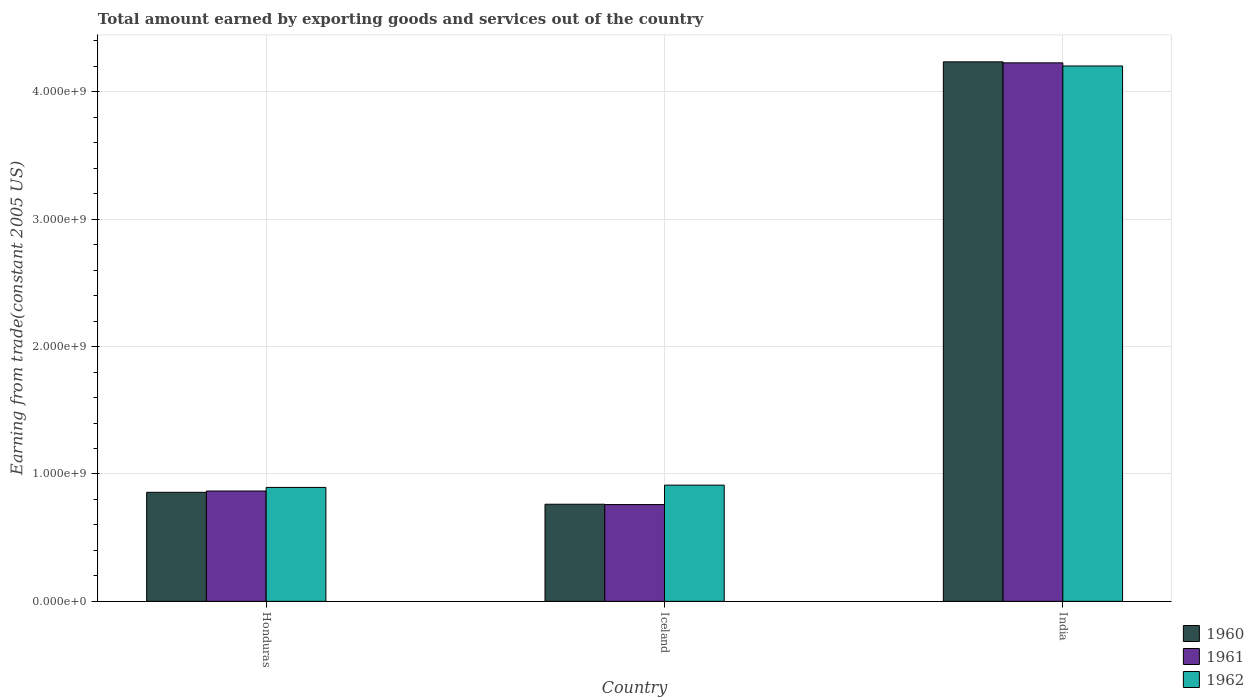How many bars are there on the 2nd tick from the left?
Offer a very short reply. 3. How many bars are there on the 2nd tick from the right?
Your response must be concise. 3. What is the label of the 3rd group of bars from the left?
Your answer should be very brief. India. What is the total amount earned by exporting goods and services in 1961 in India?
Your response must be concise. 4.23e+09. Across all countries, what is the maximum total amount earned by exporting goods and services in 1960?
Ensure brevity in your answer.  4.24e+09. Across all countries, what is the minimum total amount earned by exporting goods and services in 1961?
Make the answer very short. 7.60e+08. In which country was the total amount earned by exporting goods and services in 1962 maximum?
Your response must be concise. India. In which country was the total amount earned by exporting goods and services in 1962 minimum?
Your answer should be very brief. Honduras. What is the total total amount earned by exporting goods and services in 1962 in the graph?
Offer a very short reply. 6.01e+09. What is the difference between the total amount earned by exporting goods and services in 1962 in Honduras and that in India?
Offer a very short reply. -3.31e+09. What is the difference between the total amount earned by exporting goods and services in 1962 in Iceland and the total amount earned by exporting goods and services in 1960 in Honduras?
Offer a very short reply. 5.63e+07. What is the average total amount earned by exporting goods and services in 1960 per country?
Your response must be concise. 1.95e+09. What is the difference between the total amount earned by exporting goods and services of/in 1962 and total amount earned by exporting goods and services of/in 1961 in India?
Keep it short and to the point. -2.45e+07. What is the ratio of the total amount earned by exporting goods and services in 1960 in Honduras to that in Iceland?
Keep it short and to the point. 1.12. What is the difference between the highest and the second highest total amount earned by exporting goods and services in 1960?
Give a very brief answer. -3.38e+09. What is the difference between the highest and the lowest total amount earned by exporting goods and services in 1962?
Offer a terse response. 3.31e+09. Is the sum of the total amount earned by exporting goods and services in 1961 in Iceland and India greater than the maximum total amount earned by exporting goods and services in 1960 across all countries?
Offer a terse response. Yes. Are the values on the major ticks of Y-axis written in scientific E-notation?
Your answer should be very brief. Yes. Does the graph contain any zero values?
Give a very brief answer. No. What is the title of the graph?
Ensure brevity in your answer.  Total amount earned by exporting goods and services out of the country. What is the label or title of the Y-axis?
Provide a short and direct response. Earning from trade(constant 2005 US). What is the Earning from trade(constant 2005 US) in 1960 in Honduras?
Ensure brevity in your answer.  8.56e+08. What is the Earning from trade(constant 2005 US) of 1961 in Honduras?
Keep it short and to the point. 8.66e+08. What is the Earning from trade(constant 2005 US) of 1962 in Honduras?
Offer a very short reply. 8.95e+08. What is the Earning from trade(constant 2005 US) in 1960 in Iceland?
Make the answer very short. 7.62e+08. What is the Earning from trade(constant 2005 US) of 1961 in Iceland?
Your answer should be compact. 7.60e+08. What is the Earning from trade(constant 2005 US) in 1962 in Iceland?
Your answer should be compact. 9.12e+08. What is the Earning from trade(constant 2005 US) of 1960 in India?
Ensure brevity in your answer.  4.24e+09. What is the Earning from trade(constant 2005 US) of 1961 in India?
Your answer should be compact. 4.23e+09. What is the Earning from trade(constant 2005 US) in 1962 in India?
Provide a short and direct response. 4.20e+09. Across all countries, what is the maximum Earning from trade(constant 2005 US) of 1960?
Provide a succinct answer. 4.24e+09. Across all countries, what is the maximum Earning from trade(constant 2005 US) in 1961?
Provide a succinct answer. 4.23e+09. Across all countries, what is the maximum Earning from trade(constant 2005 US) in 1962?
Give a very brief answer. 4.20e+09. Across all countries, what is the minimum Earning from trade(constant 2005 US) of 1960?
Give a very brief answer. 7.62e+08. Across all countries, what is the minimum Earning from trade(constant 2005 US) of 1961?
Your answer should be compact. 7.60e+08. Across all countries, what is the minimum Earning from trade(constant 2005 US) in 1962?
Ensure brevity in your answer.  8.95e+08. What is the total Earning from trade(constant 2005 US) of 1960 in the graph?
Keep it short and to the point. 5.85e+09. What is the total Earning from trade(constant 2005 US) in 1961 in the graph?
Your answer should be compact. 5.85e+09. What is the total Earning from trade(constant 2005 US) in 1962 in the graph?
Your response must be concise. 6.01e+09. What is the difference between the Earning from trade(constant 2005 US) in 1960 in Honduras and that in Iceland?
Your answer should be compact. 9.37e+07. What is the difference between the Earning from trade(constant 2005 US) in 1961 in Honduras and that in Iceland?
Ensure brevity in your answer.  1.06e+08. What is the difference between the Earning from trade(constant 2005 US) in 1962 in Honduras and that in Iceland?
Your answer should be very brief. -1.79e+07. What is the difference between the Earning from trade(constant 2005 US) in 1960 in Honduras and that in India?
Keep it short and to the point. -3.38e+09. What is the difference between the Earning from trade(constant 2005 US) in 1961 in Honduras and that in India?
Your response must be concise. -3.36e+09. What is the difference between the Earning from trade(constant 2005 US) of 1962 in Honduras and that in India?
Provide a succinct answer. -3.31e+09. What is the difference between the Earning from trade(constant 2005 US) of 1960 in Iceland and that in India?
Make the answer very short. -3.47e+09. What is the difference between the Earning from trade(constant 2005 US) of 1961 in Iceland and that in India?
Keep it short and to the point. -3.47e+09. What is the difference between the Earning from trade(constant 2005 US) in 1962 in Iceland and that in India?
Your response must be concise. -3.29e+09. What is the difference between the Earning from trade(constant 2005 US) of 1960 in Honduras and the Earning from trade(constant 2005 US) of 1961 in Iceland?
Your answer should be very brief. 9.63e+07. What is the difference between the Earning from trade(constant 2005 US) in 1960 in Honduras and the Earning from trade(constant 2005 US) in 1962 in Iceland?
Provide a short and direct response. -5.63e+07. What is the difference between the Earning from trade(constant 2005 US) of 1961 in Honduras and the Earning from trade(constant 2005 US) of 1962 in Iceland?
Ensure brevity in your answer.  -4.61e+07. What is the difference between the Earning from trade(constant 2005 US) in 1960 in Honduras and the Earning from trade(constant 2005 US) in 1961 in India?
Ensure brevity in your answer.  -3.37e+09. What is the difference between the Earning from trade(constant 2005 US) of 1960 in Honduras and the Earning from trade(constant 2005 US) of 1962 in India?
Provide a short and direct response. -3.35e+09. What is the difference between the Earning from trade(constant 2005 US) of 1961 in Honduras and the Earning from trade(constant 2005 US) of 1962 in India?
Your answer should be very brief. -3.34e+09. What is the difference between the Earning from trade(constant 2005 US) of 1960 in Iceland and the Earning from trade(constant 2005 US) of 1961 in India?
Your answer should be very brief. -3.46e+09. What is the difference between the Earning from trade(constant 2005 US) of 1960 in Iceland and the Earning from trade(constant 2005 US) of 1962 in India?
Give a very brief answer. -3.44e+09. What is the difference between the Earning from trade(constant 2005 US) in 1961 in Iceland and the Earning from trade(constant 2005 US) in 1962 in India?
Your response must be concise. -3.44e+09. What is the average Earning from trade(constant 2005 US) in 1960 per country?
Your answer should be compact. 1.95e+09. What is the average Earning from trade(constant 2005 US) of 1961 per country?
Offer a very short reply. 1.95e+09. What is the average Earning from trade(constant 2005 US) in 1962 per country?
Ensure brevity in your answer.  2.00e+09. What is the difference between the Earning from trade(constant 2005 US) in 1960 and Earning from trade(constant 2005 US) in 1961 in Honduras?
Your response must be concise. -1.02e+07. What is the difference between the Earning from trade(constant 2005 US) of 1960 and Earning from trade(constant 2005 US) of 1962 in Honduras?
Ensure brevity in your answer.  -3.84e+07. What is the difference between the Earning from trade(constant 2005 US) of 1961 and Earning from trade(constant 2005 US) of 1962 in Honduras?
Offer a terse response. -2.82e+07. What is the difference between the Earning from trade(constant 2005 US) of 1960 and Earning from trade(constant 2005 US) of 1961 in Iceland?
Ensure brevity in your answer.  2.61e+06. What is the difference between the Earning from trade(constant 2005 US) in 1960 and Earning from trade(constant 2005 US) in 1962 in Iceland?
Make the answer very short. -1.50e+08. What is the difference between the Earning from trade(constant 2005 US) of 1961 and Earning from trade(constant 2005 US) of 1962 in Iceland?
Offer a very short reply. -1.53e+08. What is the difference between the Earning from trade(constant 2005 US) in 1960 and Earning from trade(constant 2005 US) in 1961 in India?
Provide a succinct answer. 7.87e+06. What is the difference between the Earning from trade(constant 2005 US) of 1960 and Earning from trade(constant 2005 US) of 1962 in India?
Your answer should be very brief. 3.24e+07. What is the difference between the Earning from trade(constant 2005 US) in 1961 and Earning from trade(constant 2005 US) in 1962 in India?
Your response must be concise. 2.45e+07. What is the ratio of the Earning from trade(constant 2005 US) of 1960 in Honduras to that in Iceland?
Offer a terse response. 1.12. What is the ratio of the Earning from trade(constant 2005 US) of 1961 in Honduras to that in Iceland?
Your response must be concise. 1.14. What is the ratio of the Earning from trade(constant 2005 US) in 1962 in Honduras to that in Iceland?
Provide a succinct answer. 0.98. What is the ratio of the Earning from trade(constant 2005 US) of 1960 in Honduras to that in India?
Offer a terse response. 0.2. What is the ratio of the Earning from trade(constant 2005 US) in 1961 in Honduras to that in India?
Give a very brief answer. 0.2. What is the ratio of the Earning from trade(constant 2005 US) in 1962 in Honduras to that in India?
Offer a terse response. 0.21. What is the ratio of the Earning from trade(constant 2005 US) in 1960 in Iceland to that in India?
Offer a terse response. 0.18. What is the ratio of the Earning from trade(constant 2005 US) of 1961 in Iceland to that in India?
Ensure brevity in your answer.  0.18. What is the ratio of the Earning from trade(constant 2005 US) in 1962 in Iceland to that in India?
Keep it short and to the point. 0.22. What is the difference between the highest and the second highest Earning from trade(constant 2005 US) in 1960?
Give a very brief answer. 3.38e+09. What is the difference between the highest and the second highest Earning from trade(constant 2005 US) of 1961?
Provide a short and direct response. 3.36e+09. What is the difference between the highest and the second highest Earning from trade(constant 2005 US) of 1962?
Give a very brief answer. 3.29e+09. What is the difference between the highest and the lowest Earning from trade(constant 2005 US) in 1960?
Your answer should be very brief. 3.47e+09. What is the difference between the highest and the lowest Earning from trade(constant 2005 US) of 1961?
Keep it short and to the point. 3.47e+09. What is the difference between the highest and the lowest Earning from trade(constant 2005 US) of 1962?
Make the answer very short. 3.31e+09. 